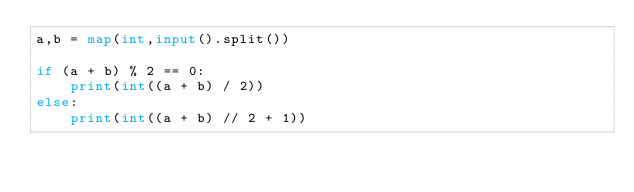<code> <loc_0><loc_0><loc_500><loc_500><_Python_>a,b = map(int,input().split())

if (a + b) % 2 == 0:
    print(int((a + b) / 2))
else:
    print(int((a + b) // 2 + 1))</code> 